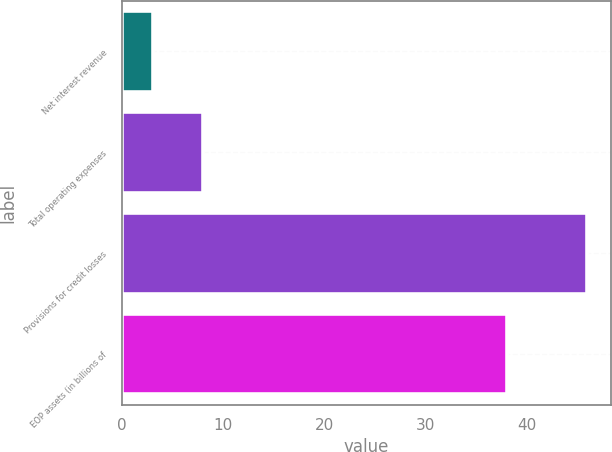<chart> <loc_0><loc_0><loc_500><loc_500><bar_chart><fcel>Net interest revenue<fcel>Total operating expenses<fcel>Provisions for credit losses<fcel>EOP assets (in billions of<nl><fcel>3<fcel>8<fcel>46<fcel>38<nl></chart> 